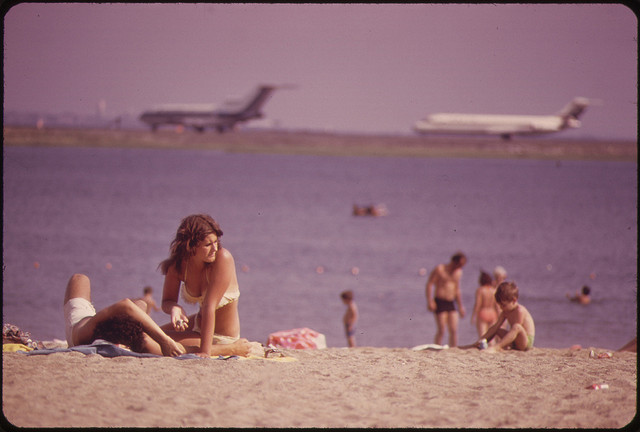What is the likely location of this beach given the presence of airplanes in such close proximity? While the exact location isn't disclosed in the image, it's reasonable to deduce that the beach is near an airport where aircraft are flying at low altitudes for takeoffs and landings. Such beaches often exist near coastal cities with urban airports; famous examples include Maho Beach in Saint Martin and the beaches near Los Angeles International Airport. The specific location would rely on additional surrounding context or landmarks. 